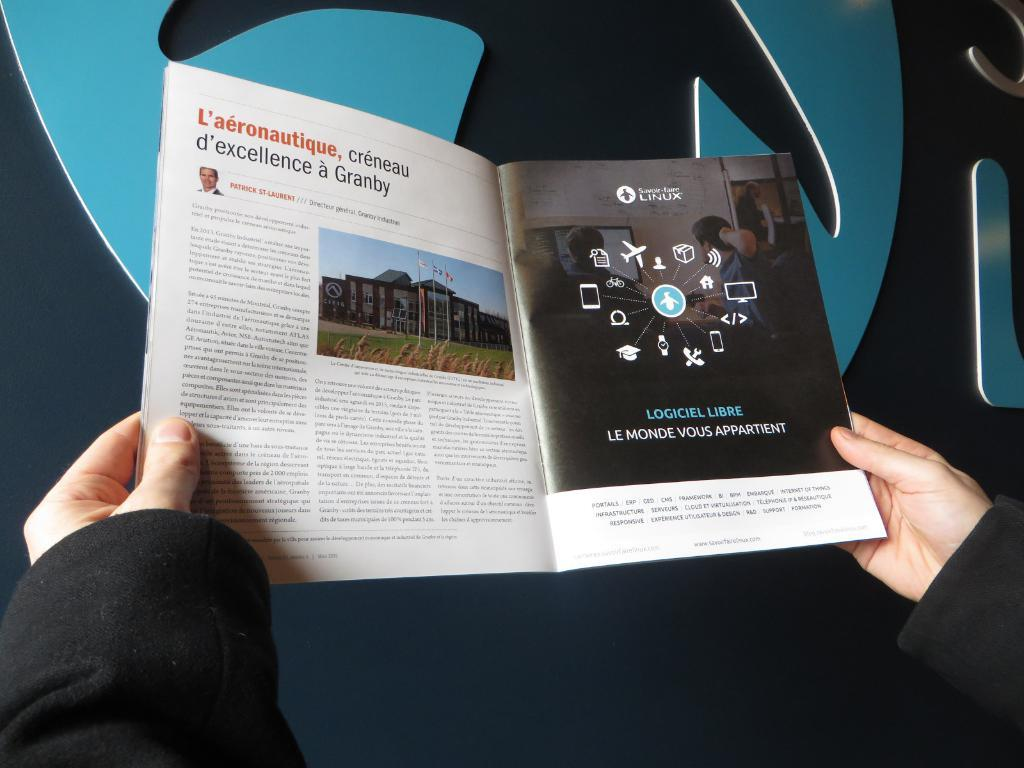<image>
Offer a succinct explanation of the picture presented. Man is reading a magazine about Linux Logiciel Libre 